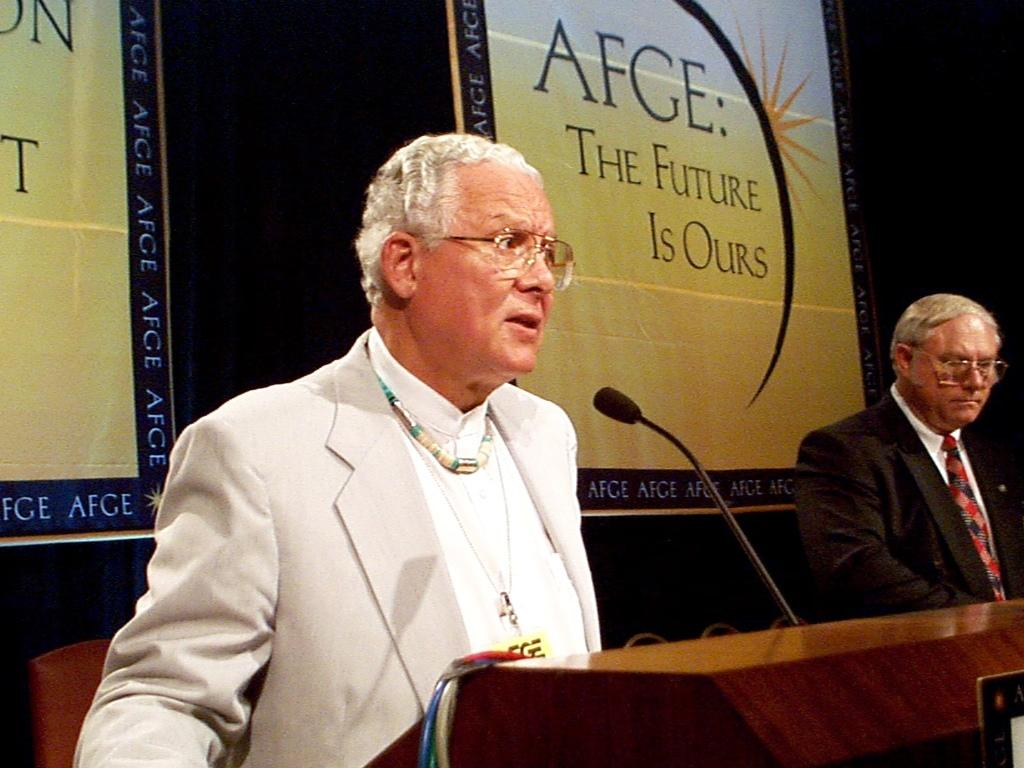What is the main subject of the image? There is a person standing on a dais in the image. What is the person on the dais doing? The person on the dais is speaking into a microphone. Is there anyone else present in the image? Yes, there is another person standing beside the person on the dais. What else can be seen in the image? There is a poster visible in the image. What type of coal can be seen in the image? There is no coal present in the image. What view can be seen from the airport in the image? There is no airport or view from an airport in the image. 